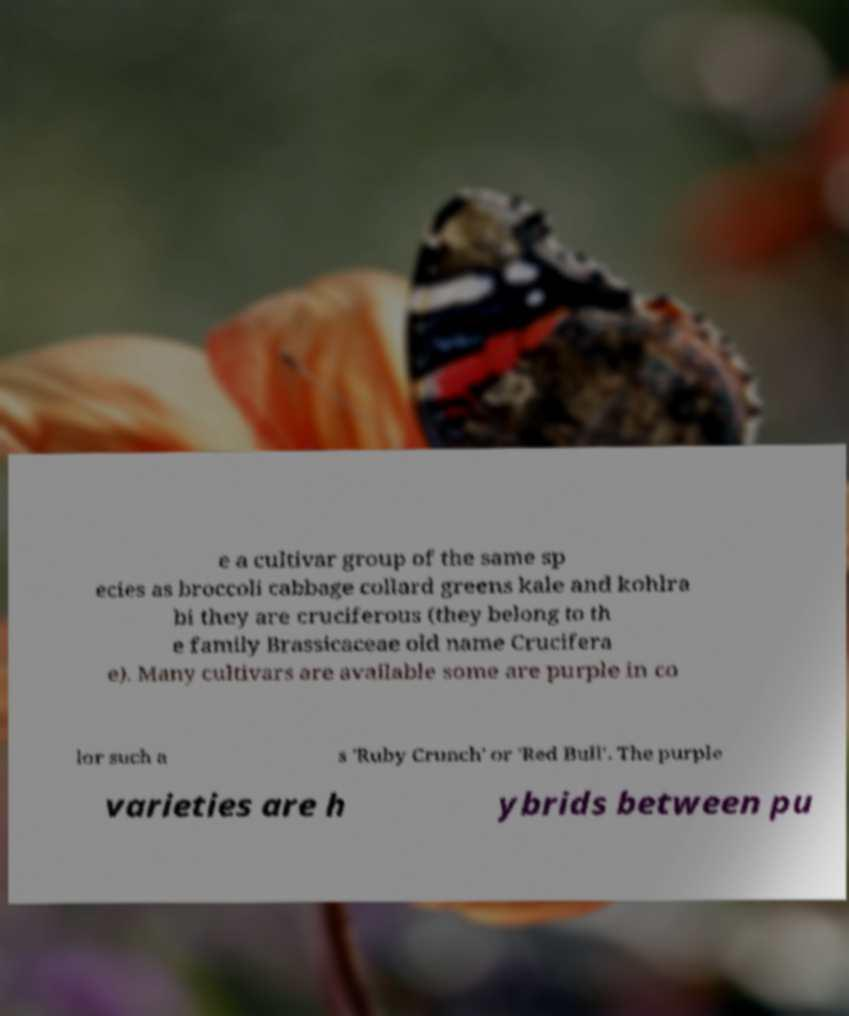For documentation purposes, I need the text within this image transcribed. Could you provide that? e a cultivar group of the same sp ecies as broccoli cabbage collard greens kale and kohlra bi they are cruciferous (they belong to th e family Brassicaceae old name Crucifera e). Many cultivars are available some are purple in co lor such a s 'Ruby Crunch' or 'Red Bull'. The purple varieties are h ybrids between pu 